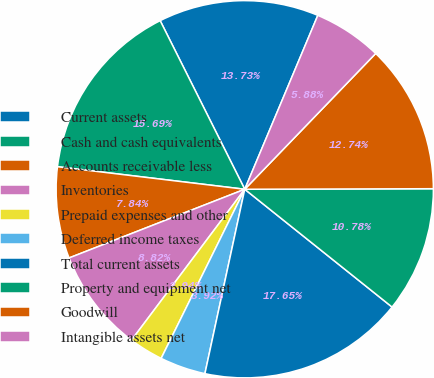Convert chart. <chart><loc_0><loc_0><loc_500><loc_500><pie_chart><fcel>Current assets<fcel>Cash and cash equivalents<fcel>Accounts receivable less<fcel>Inventories<fcel>Prepaid expenses and other<fcel>Deferred income taxes<fcel>Total current assets<fcel>Property and equipment net<fcel>Goodwill<fcel>Intangible assets net<nl><fcel>13.73%<fcel>15.69%<fcel>7.84%<fcel>8.82%<fcel>2.94%<fcel>3.92%<fcel>17.65%<fcel>10.78%<fcel>12.74%<fcel>5.88%<nl></chart> 